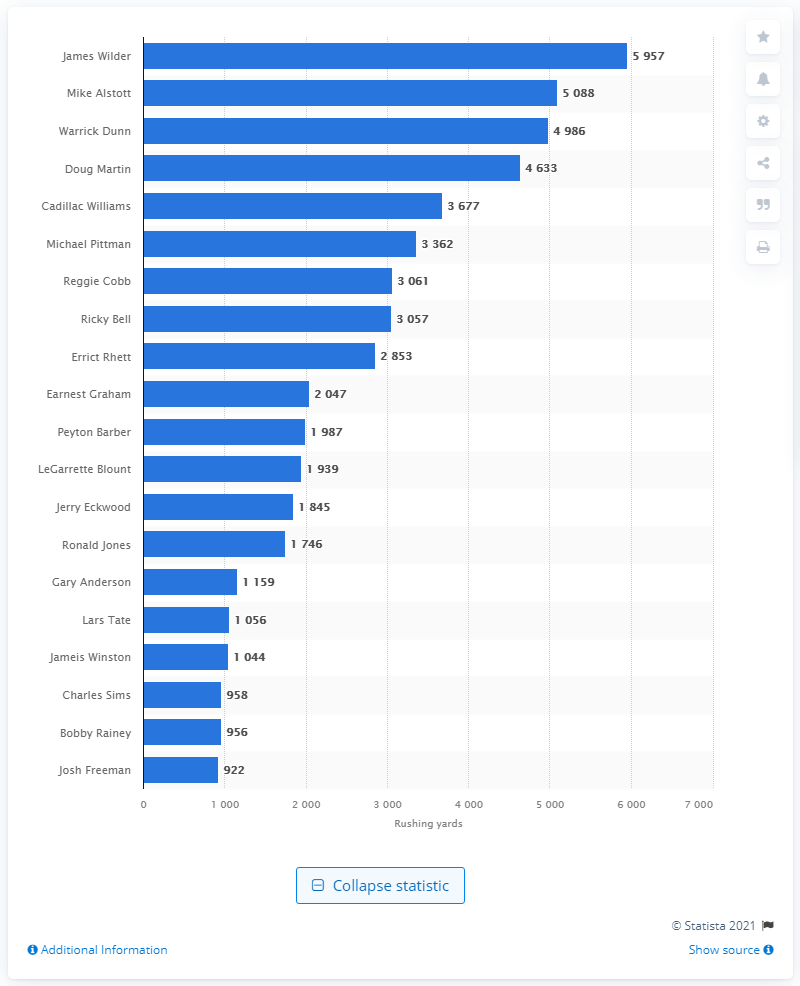Give some essential details in this illustration. The career rushing leader of the Tampa Bay Buccaneers is James Wilder. 